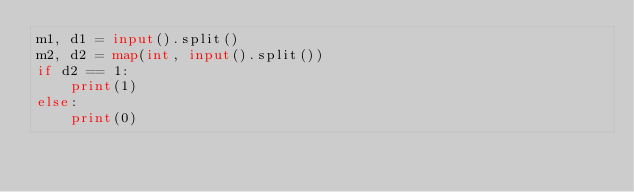<code> <loc_0><loc_0><loc_500><loc_500><_Python_>m1, d1 = input().split()
m2, d2 = map(int, input().split())
if d2 == 1:
    print(1)
else:
    print(0)
</code> 